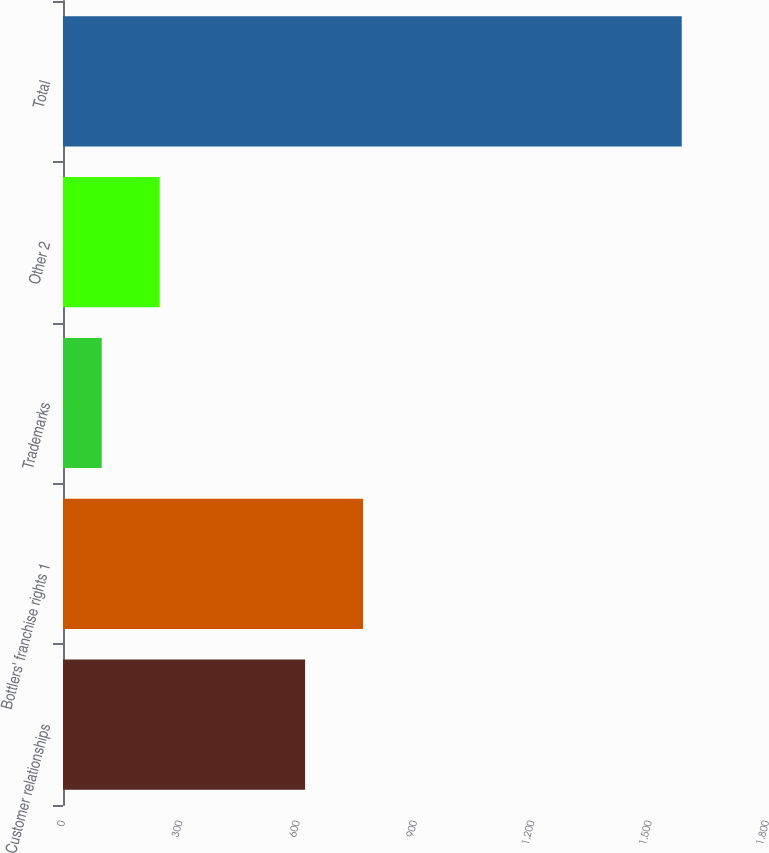<chart> <loc_0><loc_0><loc_500><loc_500><bar_chart><fcel>Customer relationships<fcel>Bottlers' franchise rights 1<fcel>Trademarks<fcel>Other 2<fcel>Total<nl><fcel>619<fcel>767.3<fcel>99<fcel>247.3<fcel>1582<nl></chart> 